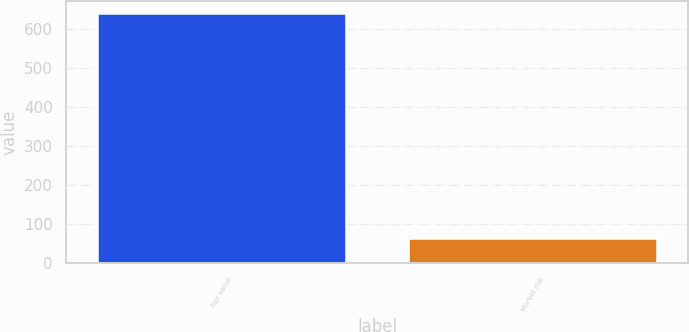<chart> <loc_0><loc_0><loc_500><loc_500><bar_chart><fcel>Fair value<fcel>Market risk<nl><fcel>640<fcel>64<nl></chart> 